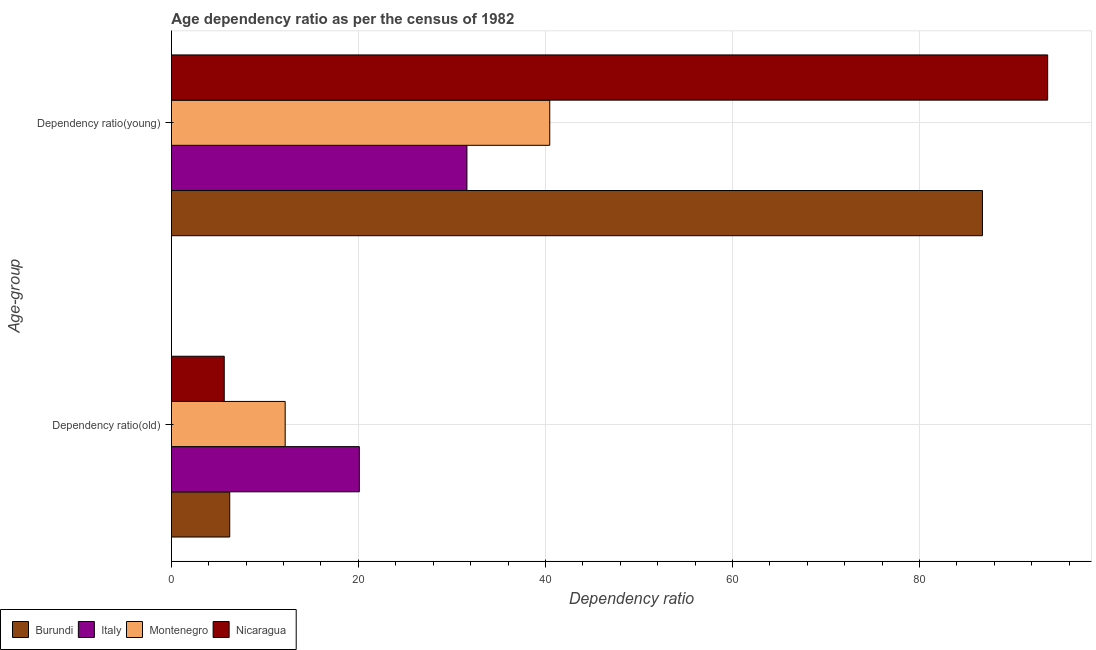How many groups of bars are there?
Keep it short and to the point. 2. Are the number of bars on each tick of the Y-axis equal?
Offer a terse response. Yes. How many bars are there on the 2nd tick from the top?
Offer a terse response. 4. How many bars are there on the 1st tick from the bottom?
Offer a very short reply. 4. What is the label of the 1st group of bars from the top?
Your answer should be compact. Dependency ratio(young). What is the age dependency ratio(old) in Italy?
Your answer should be compact. 20.1. Across all countries, what is the maximum age dependency ratio(old)?
Offer a terse response. 20.1. Across all countries, what is the minimum age dependency ratio(old)?
Ensure brevity in your answer.  5.65. In which country was the age dependency ratio(old) minimum?
Give a very brief answer. Nicaragua. What is the total age dependency ratio(old) in the graph?
Give a very brief answer. 44.16. What is the difference between the age dependency ratio(young) in Italy and that in Burundi?
Provide a succinct answer. -55.13. What is the difference between the age dependency ratio(young) in Montenegro and the age dependency ratio(old) in Nicaragua?
Ensure brevity in your answer.  34.81. What is the average age dependency ratio(old) per country?
Your answer should be very brief. 11.04. What is the difference between the age dependency ratio(young) and age dependency ratio(old) in Montenegro?
Keep it short and to the point. 28.29. In how many countries, is the age dependency ratio(old) greater than 48 ?
Offer a very short reply. 0. What is the ratio of the age dependency ratio(young) in Burundi to that in Nicaragua?
Offer a very short reply. 0.93. In how many countries, is the age dependency ratio(young) greater than the average age dependency ratio(young) taken over all countries?
Provide a short and direct response. 2. What does the 1st bar from the top in Dependency ratio(young) represents?
Provide a succinct answer. Nicaragua. What does the 3rd bar from the bottom in Dependency ratio(old) represents?
Keep it short and to the point. Montenegro. What is the difference between two consecutive major ticks on the X-axis?
Your answer should be compact. 20. Are the values on the major ticks of X-axis written in scientific E-notation?
Offer a very short reply. No. How are the legend labels stacked?
Offer a terse response. Horizontal. What is the title of the graph?
Offer a terse response. Age dependency ratio as per the census of 1982. What is the label or title of the X-axis?
Your answer should be very brief. Dependency ratio. What is the label or title of the Y-axis?
Ensure brevity in your answer.  Age-group. What is the Dependency ratio in Burundi in Dependency ratio(old)?
Provide a succinct answer. 6.24. What is the Dependency ratio of Italy in Dependency ratio(old)?
Offer a terse response. 20.1. What is the Dependency ratio of Montenegro in Dependency ratio(old)?
Keep it short and to the point. 12.17. What is the Dependency ratio in Nicaragua in Dependency ratio(old)?
Provide a succinct answer. 5.65. What is the Dependency ratio of Burundi in Dependency ratio(young)?
Your response must be concise. 86.74. What is the Dependency ratio in Italy in Dependency ratio(young)?
Ensure brevity in your answer.  31.61. What is the Dependency ratio in Montenegro in Dependency ratio(young)?
Keep it short and to the point. 40.46. What is the Dependency ratio in Nicaragua in Dependency ratio(young)?
Your answer should be very brief. 93.71. Across all Age-group, what is the maximum Dependency ratio of Burundi?
Offer a very short reply. 86.74. Across all Age-group, what is the maximum Dependency ratio in Italy?
Offer a terse response. 31.61. Across all Age-group, what is the maximum Dependency ratio in Montenegro?
Keep it short and to the point. 40.46. Across all Age-group, what is the maximum Dependency ratio in Nicaragua?
Your answer should be compact. 93.71. Across all Age-group, what is the minimum Dependency ratio of Burundi?
Ensure brevity in your answer.  6.24. Across all Age-group, what is the minimum Dependency ratio of Italy?
Your answer should be very brief. 20.1. Across all Age-group, what is the minimum Dependency ratio in Montenegro?
Offer a very short reply. 12.17. Across all Age-group, what is the minimum Dependency ratio of Nicaragua?
Offer a very short reply. 5.65. What is the total Dependency ratio of Burundi in the graph?
Provide a succinct answer. 92.98. What is the total Dependency ratio of Italy in the graph?
Provide a short and direct response. 51.71. What is the total Dependency ratio in Montenegro in the graph?
Give a very brief answer. 52.63. What is the total Dependency ratio in Nicaragua in the graph?
Your response must be concise. 99.37. What is the difference between the Dependency ratio of Burundi in Dependency ratio(old) and that in Dependency ratio(young)?
Make the answer very short. -80.5. What is the difference between the Dependency ratio in Italy in Dependency ratio(old) and that in Dependency ratio(young)?
Offer a terse response. -11.51. What is the difference between the Dependency ratio in Montenegro in Dependency ratio(old) and that in Dependency ratio(young)?
Offer a very short reply. -28.29. What is the difference between the Dependency ratio in Nicaragua in Dependency ratio(old) and that in Dependency ratio(young)?
Offer a terse response. -88.06. What is the difference between the Dependency ratio in Burundi in Dependency ratio(old) and the Dependency ratio in Italy in Dependency ratio(young)?
Your answer should be compact. -25.37. What is the difference between the Dependency ratio in Burundi in Dependency ratio(old) and the Dependency ratio in Montenegro in Dependency ratio(young)?
Your answer should be compact. -34.22. What is the difference between the Dependency ratio in Burundi in Dependency ratio(old) and the Dependency ratio in Nicaragua in Dependency ratio(young)?
Your answer should be compact. -87.47. What is the difference between the Dependency ratio of Italy in Dependency ratio(old) and the Dependency ratio of Montenegro in Dependency ratio(young)?
Keep it short and to the point. -20.36. What is the difference between the Dependency ratio in Italy in Dependency ratio(old) and the Dependency ratio in Nicaragua in Dependency ratio(young)?
Ensure brevity in your answer.  -73.61. What is the difference between the Dependency ratio of Montenegro in Dependency ratio(old) and the Dependency ratio of Nicaragua in Dependency ratio(young)?
Your answer should be compact. -81.55. What is the average Dependency ratio of Burundi per Age-group?
Keep it short and to the point. 46.49. What is the average Dependency ratio in Italy per Age-group?
Give a very brief answer. 25.85. What is the average Dependency ratio in Montenegro per Age-group?
Your answer should be compact. 26.32. What is the average Dependency ratio of Nicaragua per Age-group?
Keep it short and to the point. 49.68. What is the difference between the Dependency ratio of Burundi and Dependency ratio of Italy in Dependency ratio(old)?
Provide a short and direct response. -13.86. What is the difference between the Dependency ratio in Burundi and Dependency ratio in Montenegro in Dependency ratio(old)?
Offer a terse response. -5.93. What is the difference between the Dependency ratio of Burundi and Dependency ratio of Nicaragua in Dependency ratio(old)?
Give a very brief answer. 0.59. What is the difference between the Dependency ratio in Italy and Dependency ratio in Montenegro in Dependency ratio(old)?
Your answer should be very brief. 7.93. What is the difference between the Dependency ratio in Italy and Dependency ratio in Nicaragua in Dependency ratio(old)?
Ensure brevity in your answer.  14.45. What is the difference between the Dependency ratio in Montenegro and Dependency ratio in Nicaragua in Dependency ratio(old)?
Give a very brief answer. 6.52. What is the difference between the Dependency ratio of Burundi and Dependency ratio of Italy in Dependency ratio(young)?
Make the answer very short. 55.13. What is the difference between the Dependency ratio of Burundi and Dependency ratio of Montenegro in Dependency ratio(young)?
Your answer should be very brief. 46.27. What is the difference between the Dependency ratio of Burundi and Dependency ratio of Nicaragua in Dependency ratio(young)?
Keep it short and to the point. -6.98. What is the difference between the Dependency ratio in Italy and Dependency ratio in Montenegro in Dependency ratio(young)?
Offer a terse response. -8.86. What is the difference between the Dependency ratio of Italy and Dependency ratio of Nicaragua in Dependency ratio(young)?
Provide a succinct answer. -62.11. What is the difference between the Dependency ratio of Montenegro and Dependency ratio of Nicaragua in Dependency ratio(young)?
Your answer should be very brief. -53.25. What is the ratio of the Dependency ratio of Burundi in Dependency ratio(old) to that in Dependency ratio(young)?
Your answer should be very brief. 0.07. What is the ratio of the Dependency ratio of Italy in Dependency ratio(old) to that in Dependency ratio(young)?
Give a very brief answer. 0.64. What is the ratio of the Dependency ratio of Montenegro in Dependency ratio(old) to that in Dependency ratio(young)?
Make the answer very short. 0.3. What is the ratio of the Dependency ratio in Nicaragua in Dependency ratio(old) to that in Dependency ratio(young)?
Ensure brevity in your answer.  0.06. What is the difference between the highest and the second highest Dependency ratio in Burundi?
Give a very brief answer. 80.5. What is the difference between the highest and the second highest Dependency ratio in Italy?
Provide a succinct answer. 11.51. What is the difference between the highest and the second highest Dependency ratio of Montenegro?
Your answer should be compact. 28.29. What is the difference between the highest and the second highest Dependency ratio of Nicaragua?
Ensure brevity in your answer.  88.06. What is the difference between the highest and the lowest Dependency ratio in Burundi?
Ensure brevity in your answer.  80.5. What is the difference between the highest and the lowest Dependency ratio in Italy?
Offer a very short reply. 11.51. What is the difference between the highest and the lowest Dependency ratio in Montenegro?
Provide a short and direct response. 28.29. What is the difference between the highest and the lowest Dependency ratio in Nicaragua?
Your answer should be compact. 88.06. 